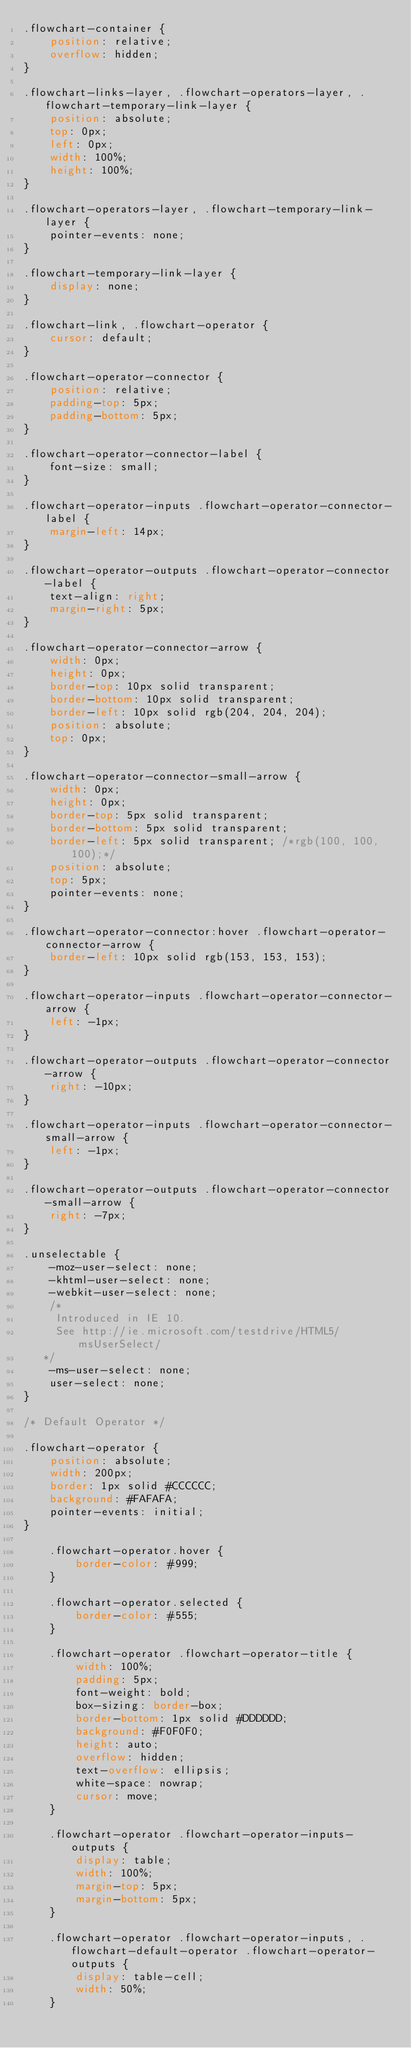Convert code to text. <code><loc_0><loc_0><loc_500><loc_500><_CSS_>.flowchart-container {
    position: relative;
    overflow: hidden;
}

.flowchart-links-layer, .flowchart-operators-layer, .flowchart-temporary-link-layer {
    position: absolute;
    top: 0px;
    left: 0px;
    width: 100%;
    height: 100%;
}

.flowchart-operators-layer, .flowchart-temporary-link-layer {
    pointer-events: none;
}

.flowchart-temporary-link-layer {
    display: none;
}

.flowchart-link, .flowchart-operator {
    cursor: default;
}

.flowchart-operator-connector {
    position: relative;
    padding-top: 5px;
    padding-bottom: 5px;
}

.flowchart-operator-connector-label {
    font-size: small;
}

.flowchart-operator-inputs .flowchart-operator-connector-label {
    margin-left: 14px;
}

.flowchart-operator-outputs .flowchart-operator-connector-label {
    text-align: right;
    margin-right: 5px;
}

.flowchart-operator-connector-arrow {
    width: 0px;
    height: 0px;
    border-top: 10px solid transparent;
    border-bottom: 10px solid transparent;
    border-left: 10px solid rgb(204, 204, 204);
    position: absolute;
    top: 0px;
}

.flowchart-operator-connector-small-arrow {
    width: 0px;
    height: 0px;
    border-top: 5px solid transparent;
    border-bottom: 5px solid transparent;
    border-left: 5px solid transparent; /*rgb(100, 100, 100);*/
    position: absolute;
    top: 5px;
    pointer-events: none;
}

.flowchart-operator-connector:hover .flowchart-operator-connector-arrow {
    border-left: 10px solid rgb(153, 153, 153);
}

.flowchart-operator-inputs .flowchart-operator-connector-arrow {
    left: -1px;
}

.flowchart-operator-outputs .flowchart-operator-connector-arrow {
    right: -10px;
}

.flowchart-operator-inputs .flowchart-operator-connector-small-arrow {
    left: -1px;
}

.flowchart-operator-outputs .flowchart-operator-connector-small-arrow {
    right: -7px;
}

.unselectable {
    -moz-user-select: none;
    -khtml-user-select: none;
    -webkit-user-select: none;
    /*
     Introduced in IE 10.
     See http://ie.microsoft.com/testdrive/HTML5/msUserSelect/
   */
    -ms-user-select: none;
    user-select: none;
}

/* Default Operator */

.flowchart-operator {
    position: absolute;
    width: 200px;
    border: 1px solid #CCCCCC;
    background: #FAFAFA;
    pointer-events: initial;
}

    .flowchart-operator.hover {
        border-color: #999;
    }

    .flowchart-operator.selected {
        border-color: #555;
    }

    .flowchart-operator .flowchart-operator-title {
        width: 100%;
        padding: 5px;
        font-weight: bold;
        box-sizing: border-box;
        border-bottom: 1px solid #DDDDDD;
        background: #F0F0F0;
        height: auto;
        overflow: hidden;
        text-overflow: ellipsis;
        white-space: nowrap;
        cursor: move;
    }

    .flowchart-operator .flowchart-operator-inputs-outputs {
        display: table;
        width: 100%;
        margin-top: 5px;
        margin-bottom: 5px;
    }

    .flowchart-operator .flowchart-operator-inputs, .flowchart-default-operator .flowchart-operator-outputs {
        display: table-cell;
        width: 50%;
    }</code> 